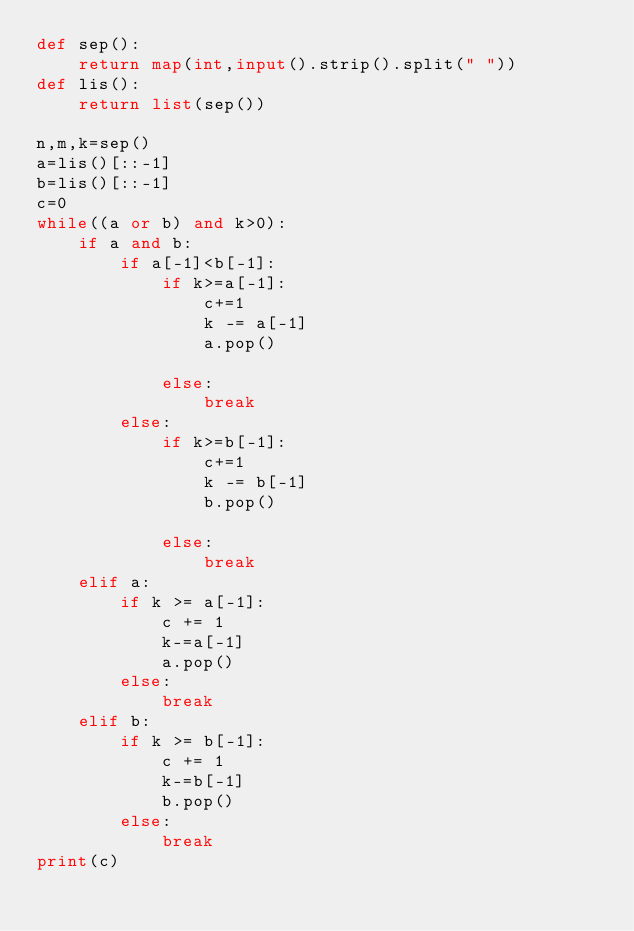<code> <loc_0><loc_0><loc_500><loc_500><_Python_>def sep():
    return map(int,input().strip().split(" "))
def lis():
    return list(sep())

n,m,k=sep()
a=lis()[::-1]
b=lis()[::-1]
c=0
while((a or b) and k>0):
    if a and b:
        if a[-1]<b[-1]:
            if k>=a[-1]:
                c+=1
                k -= a[-1]
                a.pop()

            else:
                break
        else:
            if k>=b[-1]:
                c+=1
                k -= b[-1]
                b.pop()

            else:
                break
    elif a:
        if k >= a[-1]:
            c += 1
            k-=a[-1]
            a.pop()
        else:
            break
    elif b:
        if k >= b[-1]:
            c += 1
            k-=b[-1]
            b.pop()
        else:
            break
print(c)









</code> 